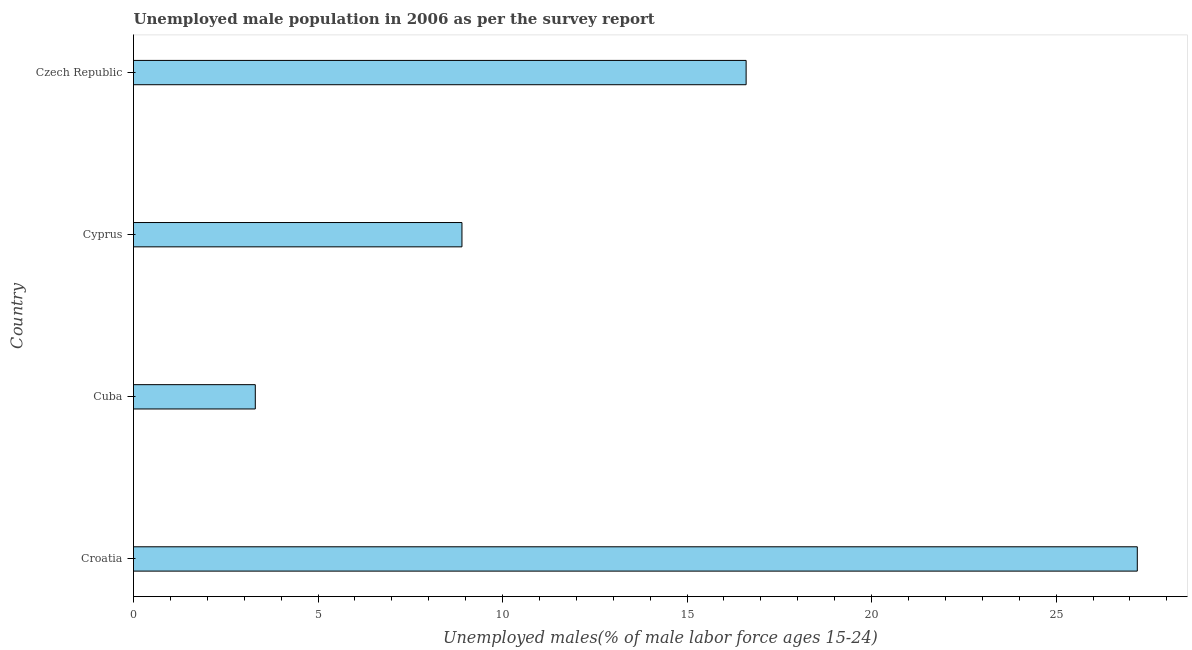Does the graph contain any zero values?
Your answer should be very brief. No. What is the title of the graph?
Ensure brevity in your answer.  Unemployed male population in 2006 as per the survey report. What is the label or title of the X-axis?
Your response must be concise. Unemployed males(% of male labor force ages 15-24). What is the unemployed male youth in Croatia?
Ensure brevity in your answer.  27.2. Across all countries, what is the maximum unemployed male youth?
Ensure brevity in your answer.  27.2. Across all countries, what is the minimum unemployed male youth?
Make the answer very short. 3.3. In which country was the unemployed male youth maximum?
Make the answer very short. Croatia. In which country was the unemployed male youth minimum?
Your answer should be very brief. Cuba. What is the sum of the unemployed male youth?
Offer a terse response. 56. What is the difference between the unemployed male youth in Croatia and Cuba?
Ensure brevity in your answer.  23.9. What is the median unemployed male youth?
Offer a terse response. 12.75. In how many countries, is the unemployed male youth greater than 13 %?
Make the answer very short. 2. What is the ratio of the unemployed male youth in Croatia to that in Czech Republic?
Give a very brief answer. 1.64. What is the difference between the highest and the second highest unemployed male youth?
Offer a terse response. 10.6. What is the difference between the highest and the lowest unemployed male youth?
Provide a succinct answer. 23.9. In how many countries, is the unemployed male youth greater than the average unemployed male youth taken over all countries?
Offer a terse response. 2. How many countries are there in the graph?
Provide a short and direct response. 4. Are the values on the major ticks of X-axis written in scientific E-notation?
Your response must be concise. No. What is the Unemployed males(% of male labor force ages 15-24) of Croatia?
Your answer should be very brief. 27.2. What is the Unemployed males(% of male labor force ages 15-24) of Cuba?
Provide a short and direct response. 3.3. What is the Unemployed males(% of male labor force ages 15-24) in Cyprus?
Provide a succinct answer. 8.9. What is the Unemployed males(% of male labor force ages 15-24) in Czech Republic?
Make the answer very short. 16.6. What is the difference between the Unemployed males(% of male labor force ages 15-24) in Croatia and Cuba?
Your answer should be compact. 23.9. What is the difference between the Unemployed males(% of male labor force ages 15-24) in Croatia and Cyprus?
Your response must be concise. 18.3. What is the difference between the Unemployed males(% of male labor force ages 15-24) in Cuba and Cyprus?
Keep it short and to the point. -5.6. What is the ratio of the Unemployed males(% of male labor force ages 15-24) in Croatia to that in Cuba?
Your response must be concise. 8.24. What is the ratio of the Unemployed males(% of male labor force ages 15-24) in Croatia to that in Cyprus?
Offer a terse response. 3.06. What is the ratio of the Unemployed males(% of male labor force ages 15-24) in Croatia to that in Czech Republic?
Offer a very short reply. 1.64. What is the ratio of the Unemployed males(% of male labor force ages 15-24) in Cuba to that in Cyprus?
Make the answer very short. 0.37. What is the ratio of the Unemployed males(% of male labor force ages 15-24) in Cuba to that in Czech Republic?
Provide a succinct answer. 0.2. What is the ratio of the Unemployed males(% of male labor force ages 15-24) in Cyprus to that in Czech Republic?
Give a very brief answer. 0.54. 